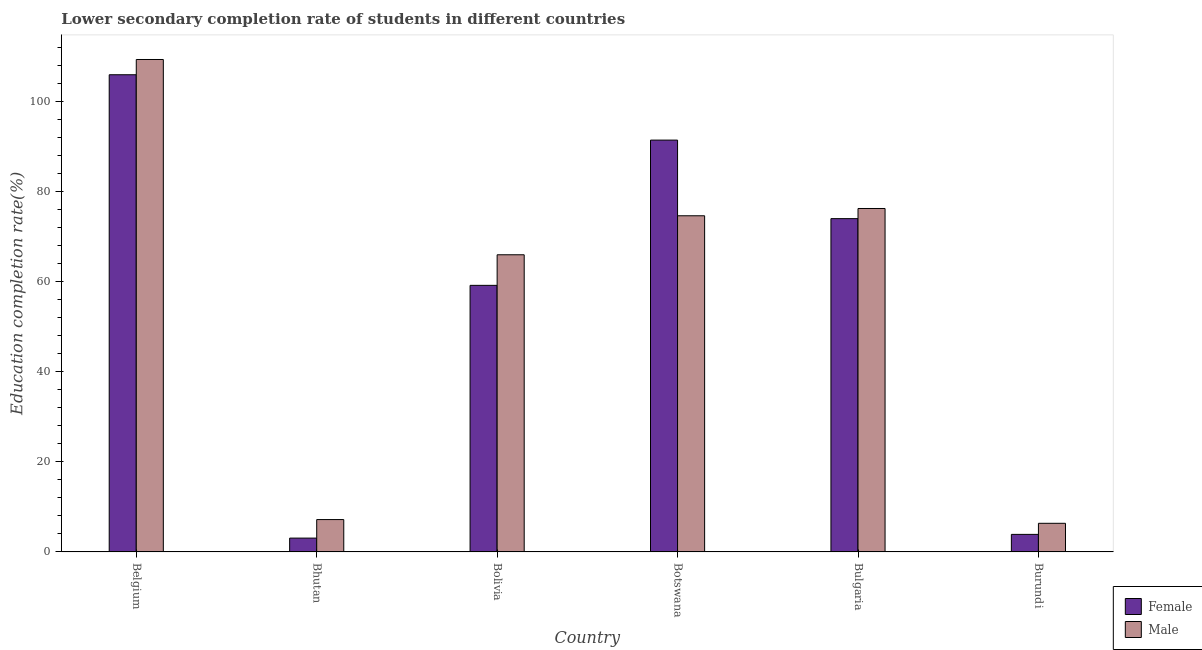How many different coloured bars are there?
Give a very brief answer. 2. Are the number of bars on each tick of the X-axis equal?
Your answer should be compact. Yes. How many bars are there on the 2nd tick from the left?
Your answer should be very brief. 2. How many bars are there on the 1st tick from the right?
Offer a terse response. 2. What is the label of the 1st group of bars from the left?
Your response must be concise. Belgium. What is the education completion rate of male students in Belgium?
Ensure brevity in your answer.  109.37. Across all countries, what is the maximum education completion rate of male students?
Your answer should be very brief. 109.37. Across all countries, what is the minimum education completion rate of male students?
Keep it short and to the point. 6.35. In which country was the education completion rate of female students maximum?
Provide a succinct answer. Belgium. In which country was the education completion rate of male students minimum?
Offer a terse response. Burundi. What is the total education completion rate of male students in the graph?
Ensure brevity in your answer.  339.83. What is the difference between the education completion rate of male students in Bolivia and that in Burundi?
Offer a very short reply. 59.64. What is the difference between the education completion rate of female students in Bolivia and the education completion rate of male students in Botswana?
Make the answer very short. -15.45. What is the average education completion rate of female students per country?
Offer a terse response. 56.27. What is the difference between the education completion rate of female students and education completion rate of male students in Bolivia?
Keep it short and to the point. -6.79. In how many countries, is the education completion rate of male students greater than 72 %?
Make the answer very short. 3. What is the ratio of the education completion rate of female students in Botswana to that in Burundi?
Offer a very short reply. 23.5. What is the difference between the highest and the second highest education completion rate of female students?
Give a very brief answer. 14.52. What is the difference between the highest and the lowest education completion rate of female students?
Offer a very short reply. 102.91. How many bars are there?
Offer a very short reply. 12. How many countries are there in the graph?
Your answer should be very brief. 6. How many legend labels are there?
Your answer should be compact. 2. What is the title of the graph?
Your answer should be compact. Lower secondary completion rate of students in different countries. What is the label or title of the X-axis?
Your answer should be compact. Country. What is the label or title of the Y-axis?
Your answer should be compact. Education completion rate(%). What is the Education completion rate(%) in Female in Belgium?
Offer a very short reply. 105.98. What is the Education completion rate(%) of Male in Belgium?
Provide a succinct answer. 109.37. What is the Education completion rate(%) in Female in Bhutan?
Make the answer very short. 3.07. What is the Education completion rate(%) in Male in Bhutan?
Keep it short and to the point. 7.18. What is the Education completion rate(%) of Female in Bolivia?
Ensure brevity in your answer.  59.2. What is the Education completion rate(%) in Male in Bolivia?
Give a very brief answer. 66. What is the Education completion rate(%) of Female in Botswana?
Your answer should be very brief. 91.46. What is the Education completion rate(%) of Male in Botswana?
Give a very brief answer. 74.66. What is the Education completion rate(%) of Female in Bulgaria?
Provide a short and direct response. 74.02. What is the Education completion rate(%) of Male in Bulgaria?
Your response must be concise. 76.27. What is the Education completion rate(%) in Female in Burundi?
Make the answer very short. 3.89. What is the Education completion rate(%) in Male in Burundi?
Give a very brief answer. 6.35. Across all countries, what is the maximum Education completion rate(%) in Female?
Ensure brevity in your answer.  105.98. Across all countries, what is the maximum Education completion rate(%) in Male?
Your answer should be compact. 109.37. Across all countries, what is the minimum Education completion rate(%) of Female?
Your answer should be compact. 3.07. Across all countries, what is the minimum Education completion rate(%) of Male?
Your answer should be compact. 6.35. What is the total Education completion rate(%) in Female in the graph?
Offer a terse response. 337.63. What is the total Education completion rate(%) of Male in the graph?
Your response must be concise. 339.83. What is the difference between the Education completion rate(%) in Female in Belgium and that in Bhutan?
Your answer should be compact. 102.91. What is the difference between the Education completion rate(%) of Male in Belgium and that in Bhutan?
Make the answer very short. 102.18. What is the difference between the Education completion rate(%) in Female in Belgium and that in Bolivia?
Give a very brief answer. 46.78. What is the difference between the Education completion rate(%) in Male in Belgium and that in Bolivia?
Make the answer very short. 43.37. What is the difference between the Education completion rate(%) of Female in Belgium and that in Botswana?
Provide a succinct answer. 14.52. What is the difference between the Education completion rate(%) of Male in Belgium and that in Botswana?
Ensure brevity in your answer.  34.71. What is the difference between the Education completion rate(%) in Female in Belgium and that in Bulgaria?
Give a very brief answer. 31.96. What is the difference between the Education completion rate(%) of Male in Belgium and that in Bulgaria?
Offer a very short reply. 33.09. What is the difference between the Education completion rate(%) in Female in Belgium and that in Burundi?
Ensure brevity in your answer.  102.09. What is the difference between the Education completion rate(%) in Male in Belgium and that in Burundi?
Ensure brevity in your answer.  103.01. What is the difference between the Education completion rate(%) of Female in Bhutan and that in Bolivia?
Your answer should be compact. -56.13. What is the difference between the Education completion rate(%) in Male in Bhutan and that in Bolivia?
Provide a succinct answer. -58.81. What is the difference between the Education completion rate(%) of Female in Bhutan and that in Botswana?
Offer a terse response. -88.4. What is the difference between the Education completion rate(%) in Male in Bhutan and that in Botswana?
Provide a short and direct response. -67.47. What is the difference between the Education completion rate(%) in Female in Bhutan and that in Bulgaria?
Ensure brevity in your answer.  -70.95. What is the difference between the Education completion rate(%) in Male in Bhutan and that in Bulgaria?
Your response must be concise. -69.09. What is the difference between the Education completion rate(%) of Female in Bhutan and that in Burundi?
Offer a terse response. -0.82. What is the difference between the Education completion rate(%) of Male in Bhutan and that in Burundi?
Provide a short and direct response. 0.83. What is the difference between the Education completion rate(%) in Female in Bolivia and that in Botswana?
Your answer should be very brief. -32.26. What is the difference between the Education completion rate(%) of Male in Bolivia and that in Botswana?
Ensure brevity in your answer.  -8.66. What is the difference between the Education completion rate(%) in Female in Bolivia and that in Bulgaria?
Your answer should be compact. -14.82. What is the difference between the Education completion rate(%) of Male in Bolivia and that in Bulgaria?
Make the answer very short. -10.28. What is the difference between the Education completion rate(%) of Female in Bolivia and that in Burundi?
Ensure brevity in your answer.  55.31. What is the difference between the Education completion rate(%) in Male in Bolivia and that in Burundi?
Keep it short and to the point. 59.64. What is the difference between the Education completion rate(%) in Female in Botswana and that in Bulgaria?
Give a very brief answer. 17.44. What is the difference between the Education completion rate(%) of Male in Botswana and that in Bulgaria?
Your response must be concise. -1.62. What is the difference between the Education completion rate(%) in Female in Botswana and that in Burundi?
Your answer should be compact. 87.57. What is the difference between the Education completion rate(%) of Male in Botswana and that in Burundi?
Your answer should be compact. 68.3. What is the difference between the Education completion rate(%) in Female in Bulgaria and that in Burundi?
Offer a terse response. 70.13. What is the difference between the Education completion rate(%) in Male in Bulgaria and that in Burundi?
Offer a terse response. 69.92. What is the difference between the Education completion rate(%) in Female in Belgium and the Education completion rate(%) in Male in Bhutan?
Offer a very short reply. 98.8. What is the difference between the Education completion rate(%) in Female in Belgium and the Education completion rate(%) in Male in Bolivia?
Your answer should be very brief. 39.99. What is the difference between the Education completion rate(%) of Female in Belgium and the Education completion rate(%) of Male in Botswana?
Give a very brief answer. 31.32. What is the difference between the Education completion rate(%) in Female in Belgium and the Education completion rate(%) in Male in Bulgaria?
Keep it short and to the point. 29.71. What is the difference between the Education completion rate(%) in Female in Belgium and the Education completion rate(%) in Male in Burundi?
Offer a terse response. 99.63. What is the difference between the Education completion rate(%) in Female in Bhutan and the Education completion rate(%) in Male in Bolivia?
Keep it short and to the point. -62.93. What is the difference between the Education completion rate(%) of Female in Bhutan and the Education completion rate(%) of Male in Botswana?
Your answer should be compact. -71.59. What is the difference between the Education completion rate(%) of Female in Bhutan and the Education completion rate(%) of Male in Bulgaria?
Offer a terse response. -73.21. What is the difference between the Education completion rate(%) of Female in Bhutan and the Education completion rate(%) of Male in Burundi?
Keep it short and to the point. -3.28. What is the difference between the Education completion rate(%) of Female in Bolivia and the Education completion rate(%) of Male in Botswana?
Your response must be concise. -15.45. What is the difference between the Education completion rate(%) in Female in Bolivia and the Education completion rate(%) in Male in Bulgaria?
Make the answer very short. -17.07. What is the difference between the Education completion rate(%) in Female in Bolivia and the Education completion rate(%) in Male in Burundi?
Your response must be concise. 52.85. What is the difference between the Education completion rate(%) of Female in Botswana and the Education completion rate(%) of Male in Bulgaria?
Your answer should be compact. 15.19. What is the difference between the Education completion rate(%) of Female in Botswana and the Education completion rate(%) of Male in Burundi?
Make the answer very short. 85.11. What is the difference between the Education completion rate(%) in Female in Bulgaria and the Education completion rate(%) in Male in Burundi?
Your answer should be very brief. 67.67. What is the average Education completion rate(%) of Female per country?
Keep it short and to the point. 56.27. What is the average Education completion rate(%) of Male per country?
Make the answer very short. 56.64. What is the difference between the Education completion rate(%) in Female and Education completion rate(%) in Male in Belgium?
Give a very brief answer. -3.39. What is the difference between the Education completion rate(%) in Female and Education completion rate(%) in Male in Bhutan?
Your answer should be very brief. -4.12. What is the difference between the Education completion rate(%) of Female and Education completion rate(%) of Male in Bolivia?
Provide a succinct answer. -6.79. What is the difference between the Education completion rate(%) of Female and Education completion rate(%) of Male in Botswana?
Keep it short and to the point. 16.81. What is the difference between the Education completion rate(%) in Female and Education completion rate(%) in Male in Bulgaria?
Your answer should be compact. -2.26. What is the difference between the Education completion rate(%) of Female and Education completion rate(%) of Male in Burundi?
Your answer should be very brief. -2.46. What is the ratio of the Education completion rate(%) of Female in Belgium to that in Bhutan?
Keep it short and to the point. 34.54. What is the ratio of the Education completion rate(%) in Male in Belgium to that in Bhutan?
Offer a terse response. 15.22. What is the ratio of the Education completion rate(%) in Female in Belgium to that in Bolivia?
Keep it short and to the point. 1.79. What is the ratio of the Education completion rate(%) of Male in Belgium to that in Bolivia?
Provide a succinct answer. 1.66. What is the ratio of the Education completion rate(%) in Female in Belgium to that in Botswana?
Your answer should be very brief. 1.16. What is the ratio of the Education completion rate(%) of Male in Belgium to that in Botswana?
Make the answer very short. 1.46. What is the ratio of the Education completion rate(%) of Female in Belgium to that in Bulgaria?
Make the answer very short. 1.43. What is the ratio of the Education completion rate(%) in Male in Belgium to that in Bulgaria?
Keep it short and to the point. 1.43. What is the ratio of the Education completion rate(%) in Female in Belgium to that in Burundi?
Your answer should be very brief. 27.23. What is the ratio of the Education completion rate(%) in Male in Belgium to that in Burundi?
Keep it short and to the point. 17.22. What is the ratio of the Education completion rate(%) in Female in Bhutan to that in Bolivia?
Offer a terse response. 0.05. What is the ratio of the Education completion rate(%) in Male in Bhutan to that in Bolivia?
Your response must be concise. 0.11. What is the ratio of the Education completion rate(%) in Female in Bhutan to that in Botswana?
Your answer should be compact. 0.03. What is the ratio of the Education completion rate(%) in Male in Bhutan to that in Botswana?
Keep it short and to the point. 0.1. What is the ratio of the Education completion rate(%) of Female in Bhutan to that in Bulgaria?
Offer a very short reply. 0.04. What is the ratio of the Education completion rate(%) in Male in Bhutan to that in Bulgaria?
Offer a terse response. 0.09. What is the ratio of the Education completion rate(%) in Female in Bhutan to that in Burundi?
Give a very brief answer. 0.79. What is the ratio of the Education completion rate(%) of Male in Bhutan to that in Burundi?
Your response must be concise. 1.13. What is the ratio of the Education completion rate(%) in Female in Bolivia to that in Botswana?
Ensure brevity in your answer.  0.65. What is the ratio of the Education completion rate(%) in Male in Bolivia to that in Botswana?
Offer a terse response. 0.88. What is the ratio of the Education completion rate(%) of Female in Bolivia to that in Bulgaria?
Your response must be concise. 0.8. What is the ratio of the Education completion rate(%) of Male in Bolivia to that in Bulgaria?
Offer a terse response. 0.87. What is the ratio of the Education completion rate(%) of Female in Bolivia to that in Burundi?
Your response must be concise. 15.21. What is the ratio of the Education completion rate(%) in Male in Bolivia to that in Burundi?
Your answer should be compact. 10.39. What is the ratio of the Education completion rate(%) in Female in Botswana to that in Bulgaria?
Make the answer very short. 1.24. What is the ratio of the Education completion rate(%) of Male in Botswana to that in Bulgaria?
Your answer should be compact. 0.98. What is the ratio of the Education completion rate(%) in Female in Botswana to that in Burundi?
Offer a terse response. 23.5. What is the ratio of the Education completion rate(%) of Male in Botswana to that in Burundi?
Keep it short and to the point. 11.75. What is the ratio of the Education completion rate(%) in Female in Bulgaria to that in Burundi?
Offer a terse response. 19.02. What is the ratio of the Education completion rate(%) of Male in Bulgaria to that in Burundi?
Ensure brevity in your answer.  12.01. What is the difference between the highest and the second highest Education completion rate(%) in Female?
Provide a short and direct response. 14.52. What is the difference between the highest and the second highest Education completion rate(%) of Male?
Keep it short and to the point. 33.09. What is the difference between the highest and the lowest Education completion rate(%) of Female?
Your answer should be compact. 102.91. What is the difference between the highest and the lowest Education completion rate(%) of Male?
Give a very brief answer. 103.01. 